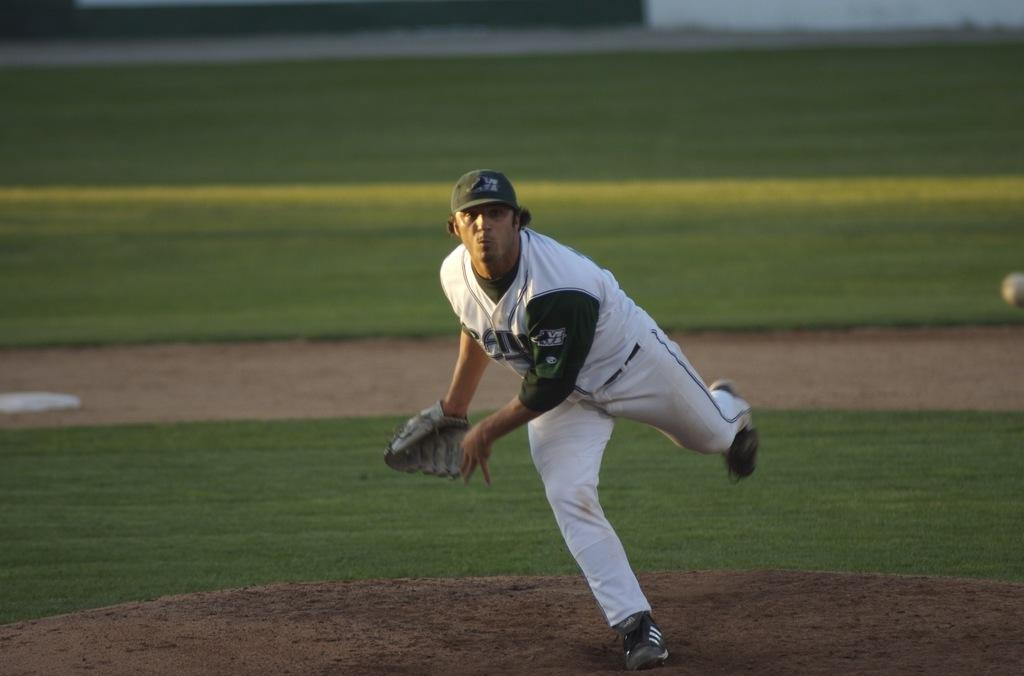What is the main subject of the image? There is a man standing in the image. What type of surface is visible beneath the man's feet? There is grass visible in the image. What type of wood can be seen in the image? There is no wood present in the image; it features a man standing on grass. 